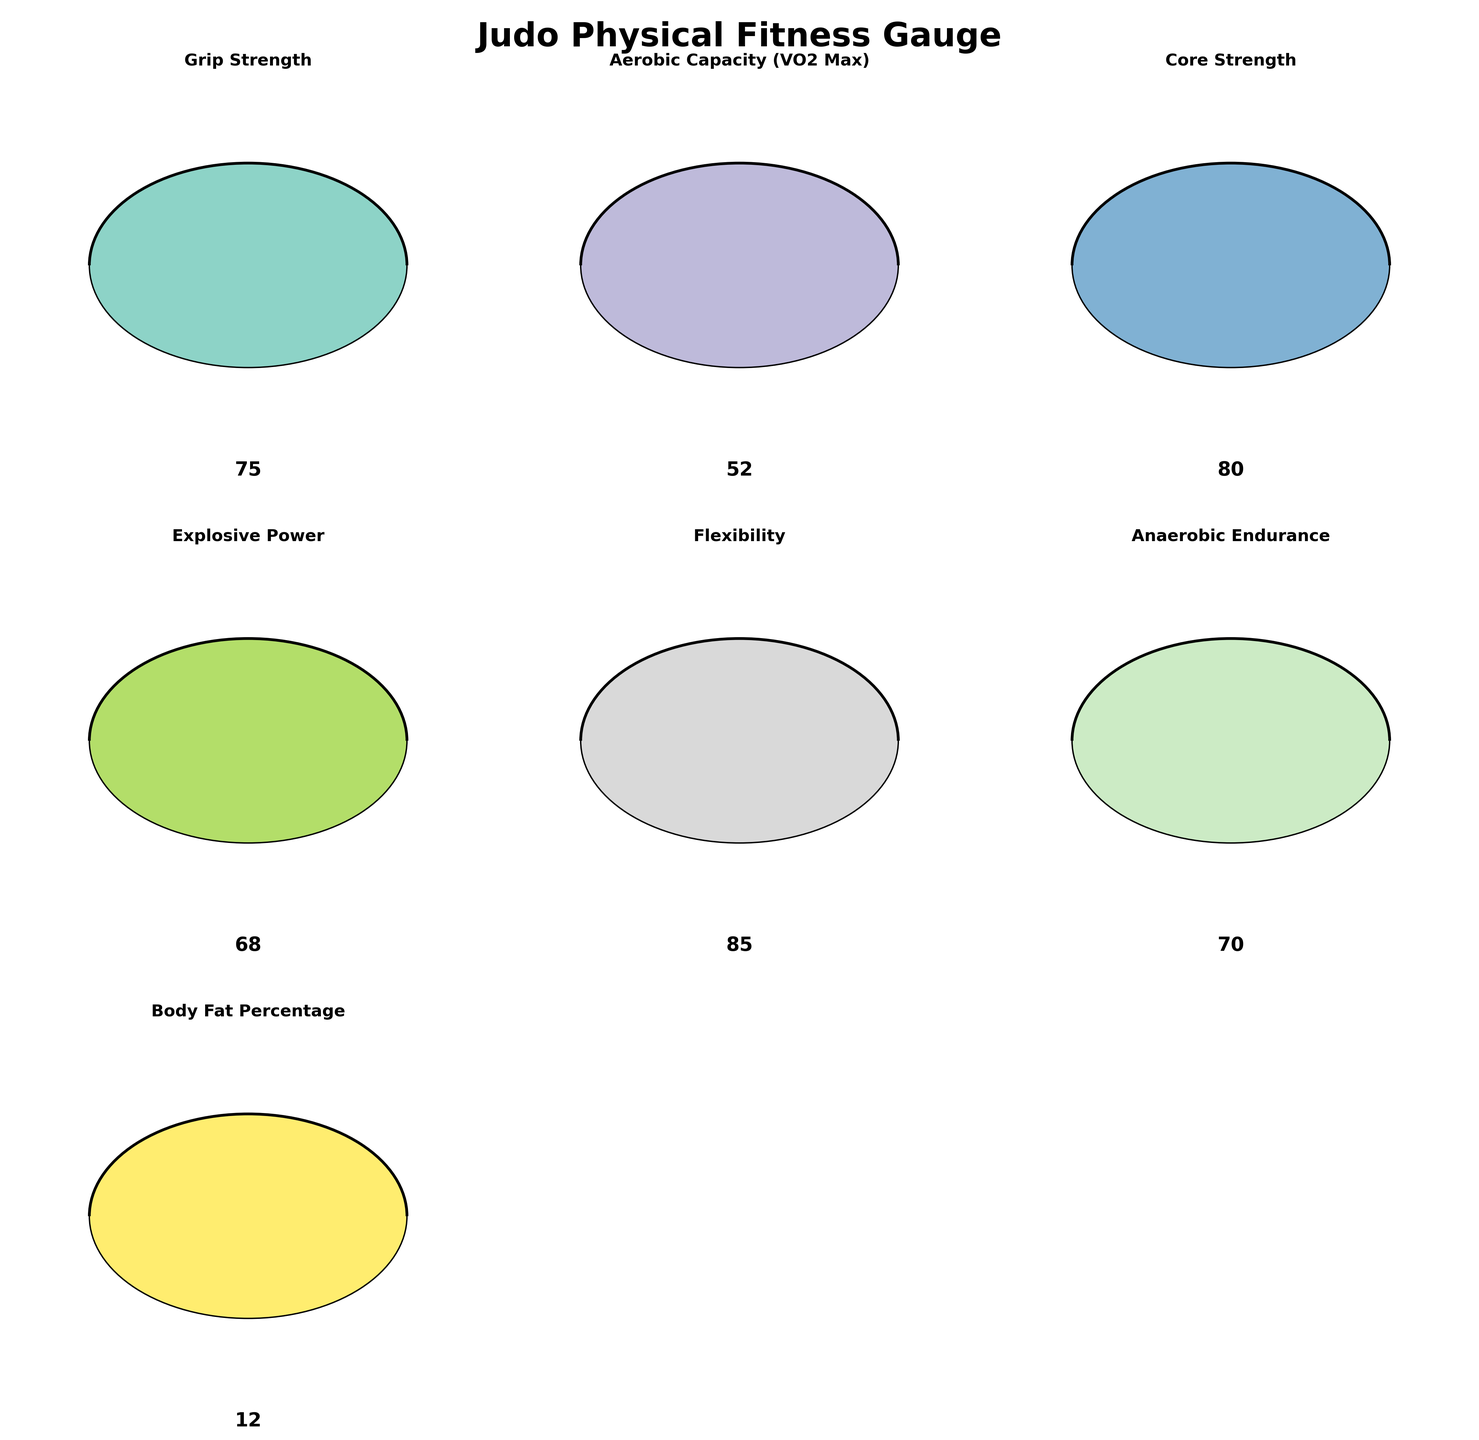what is the title of the figure? The title of the figure is typically at the top center of the plot. For this specific plot, it's set using `plt.suptitle`, which specifies the title “Judo Physical Fitness Gauge”. This is visually evident when looking at the figure.
Answer: "Judo Physical Fitness Gauge" How many categories of physical fitness are displayed in the figure? The data provided has 7 different categories of physical fitness, which are visually presented in the gauge charts: Grip Strength, Aerobic Capacity (VO2 Max), Core Strength, Explosive Power, Flexibility, Anaerobic Endurance, and Body Fat Percentage.
Answer: 7 Which physical fitness category shows the highest value on the gauge? Each gauge represents a different category with a value indicated. Among all, "Flexibility" has the highest value with a gauge reading of 85. This is evident by visually comparing the values shown on each gauge.
Answer: Flexibility (85) Which physical fitness category is furthest from the maximum value? To find the category furthest from the maximum, we compare the difference between the category's value and its maximum value. "Aerobic Capacity (VO2 Max)" with a value of 52 and a maximum of 70 has the largest discrepancy of 18.
Answer: Aerobic Capacity (18) How does the core strength value compare to the grip strength value? We look at the values indicated for each category in the gauges. Core Strength has a value of 80, whereas Grip Strength has a value of 75, so Core Strength is higher.
Answer: Core Strength (80) is higher than Grip Strength (75) What's the average value across all the physical fitness categories? Add all the category values (75 + 52 + 80 + 68 + 85 + 70 + 12) and divide by the number of categories (7). This results in (75 + 52 + 80 + 68 + 85 + 70 + 12) / 7 = 442 / 7 ≈ 63.14
Answer: 63.14 Which category's gauge is closest to being full? By observing the gauge angles, the category with the highest percentage towards the maximum would be Flexibility with a value of 85 out of 100, making it 85% full.
Answer: Flexibility (85%) If Body Fat Percentage is considered desirable when closer to the minimum, which category follows Body Fat Percentage most closely in its desirability metric? Body Fat Percentage at 12 out of 25 is closest to its minimum value. Comparing other categories to their minimum values, Flexibility at 85 out of 100 is closest to being optimal with respect to being highly desirable at closer to the maximum value.
Answer: Flexibility What is the total difference between the values for Explosive Power and Anaerobic Endurance? Look at the values for Explosive Power (68) and Anaerobic Endurance (70). The total difference is abs(68 - 70) = 2.
Answer: 2 